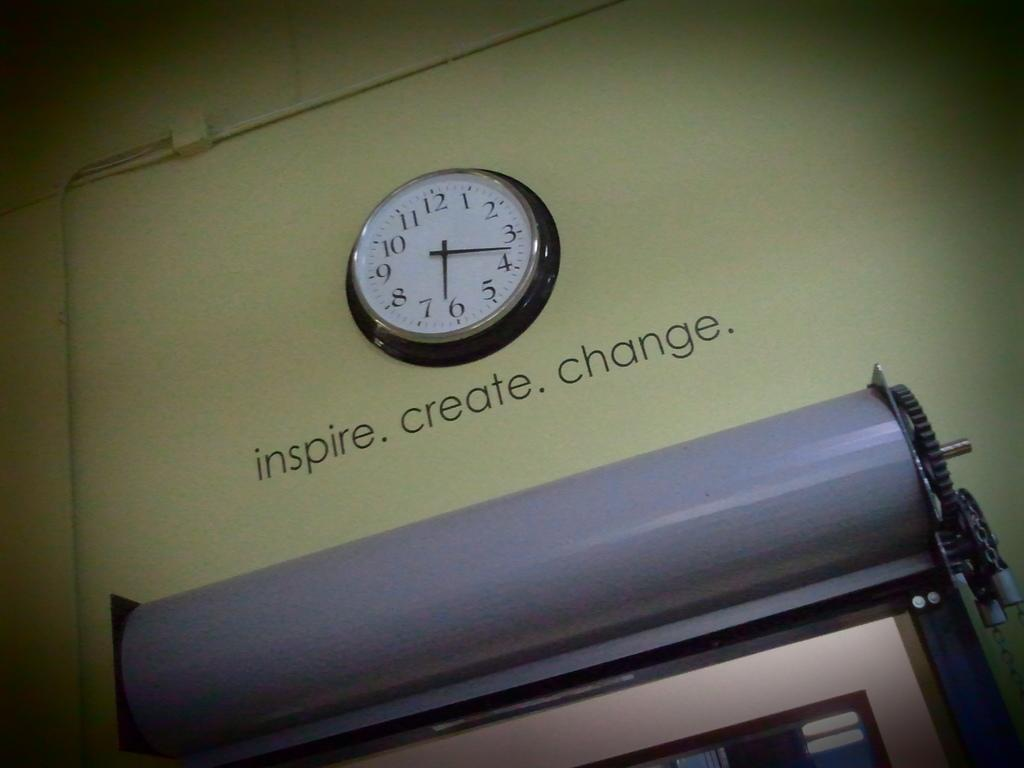Provide a one-sentence caption for the provided image. A clock at 6:17 on a tan wall with the words inspire. create, change on the wall under the clock. 